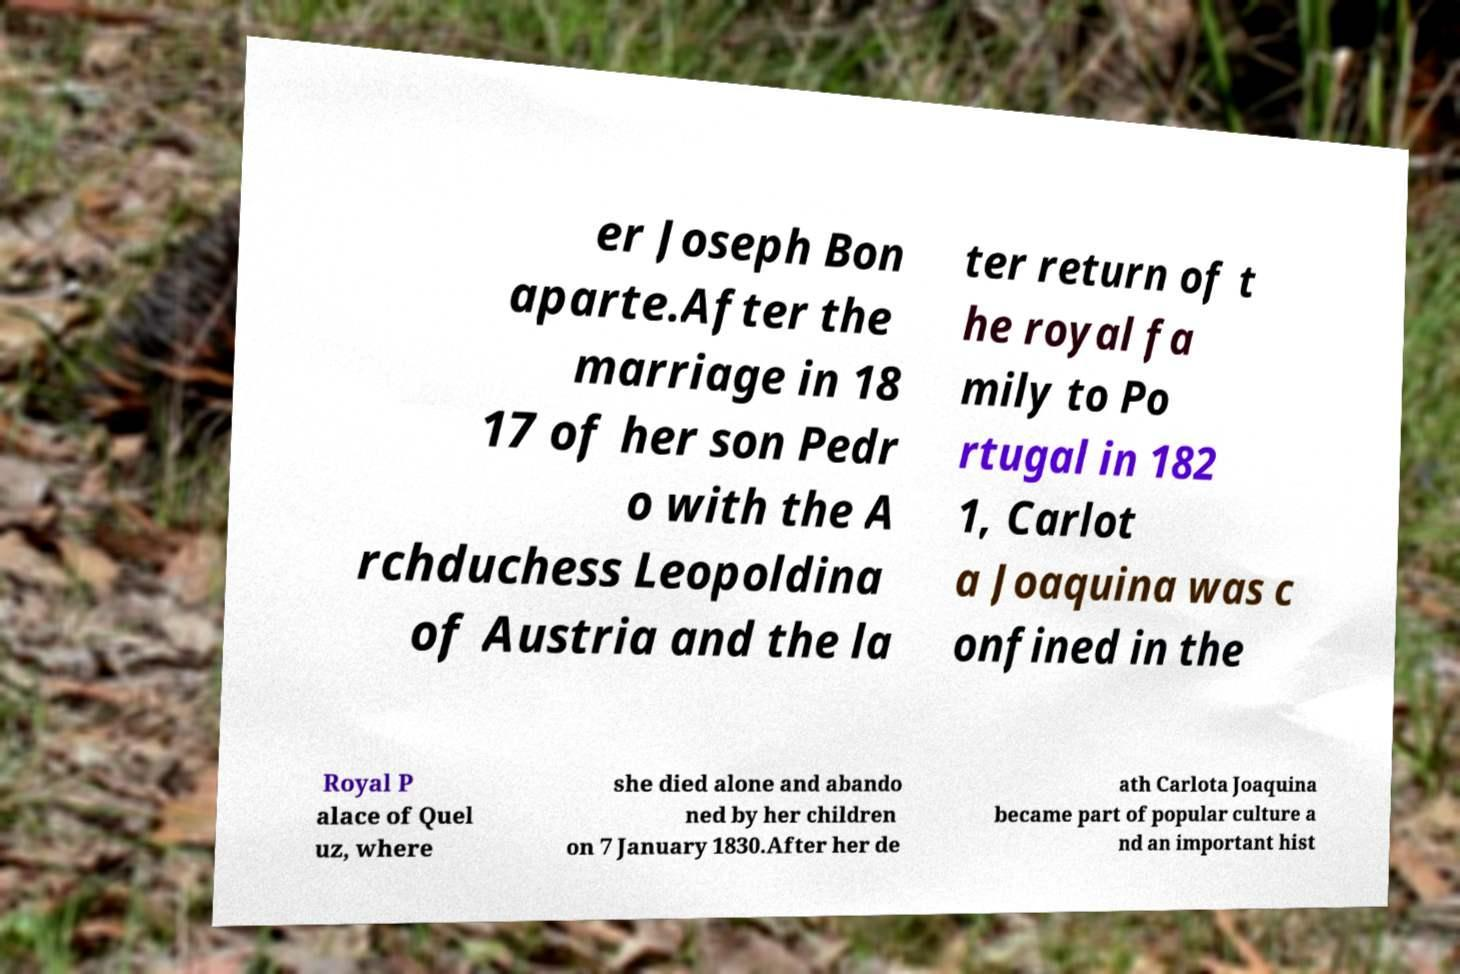I need the written content from this picture converted into text. Can you do that? er Joseph Bon aparte.After the marriage in 18 17 of her son Pedr o with the A rchduchess Leopoldina of Austria and the la ter return of t he royal fa mily to Po rtugal in 182 1, Carlot a Joaquina was c onfined in the Royal P alace of Quel uz, where she died alone and abando ned by her children on 7 January 1830.After her de ath Carlota Joaquina became part of popular culture a nd an important hist 